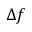<formula> <loc_0><loc_0><loc_500><loc_500>\Delta f</formula> 